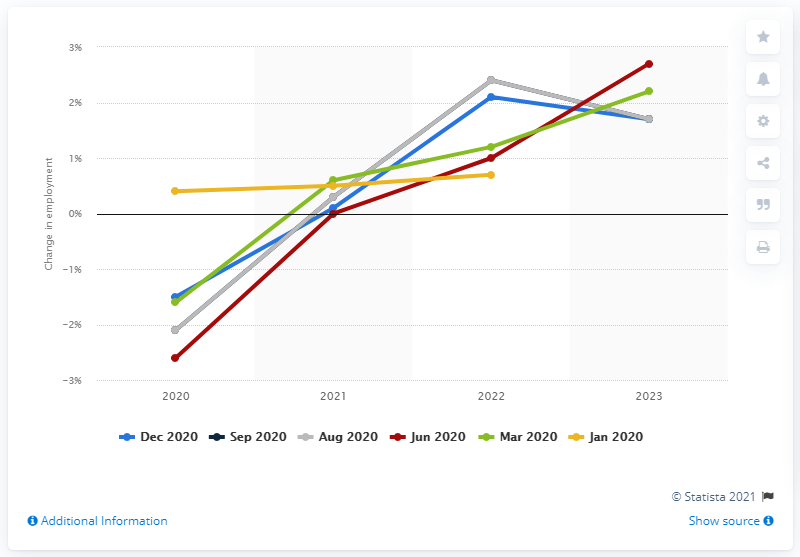Give some essential details in this illustration. According to the forecast, Sweden's employment rate was expected to be 0.4 in January 2020. 